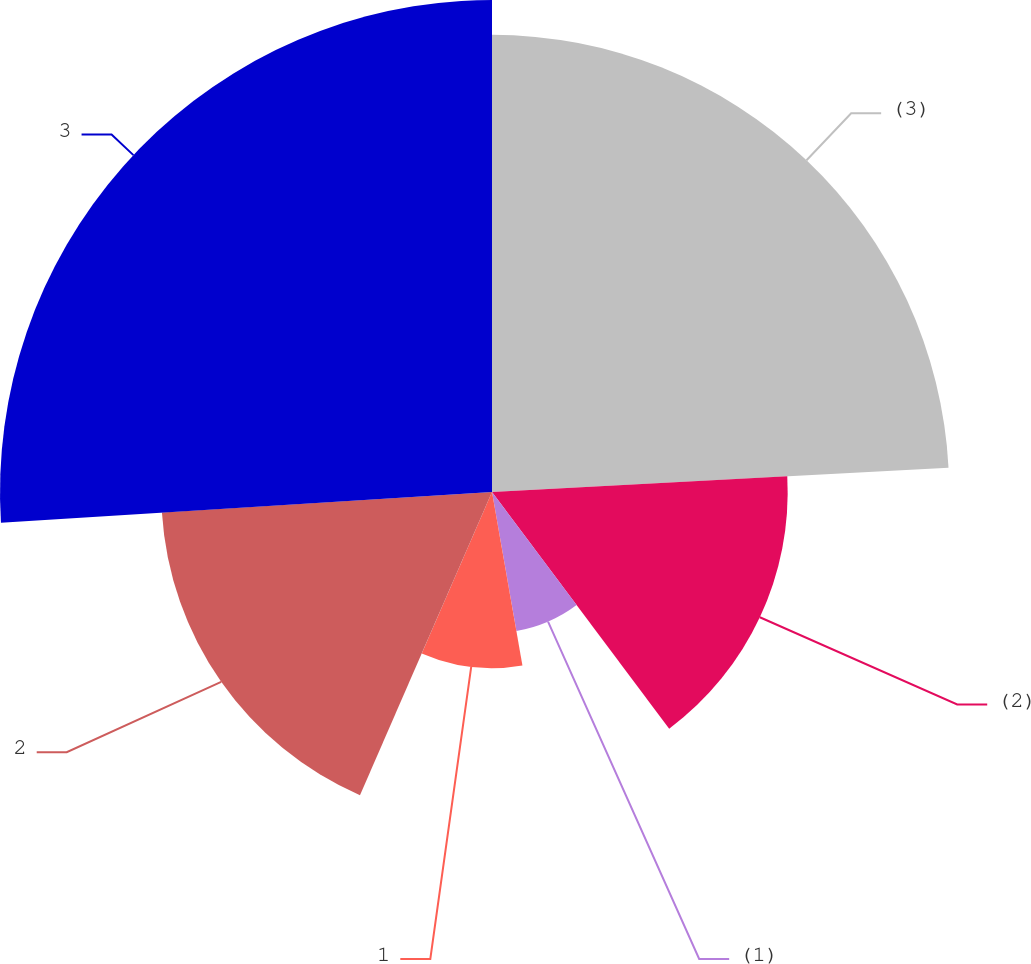<chart> <loc_0><loc_0><loc_500><loc_500><pie_chart><fcel>(3)<fcel>(2)<fcel>(1)<fcel>1<fcel>2<fcel>3<nl><fcel>24.15%<fcel>15.62%<fcel>7.46%<fcel>9.3%<fcel>17.47%<fcel>25.99%<nl></chart> 